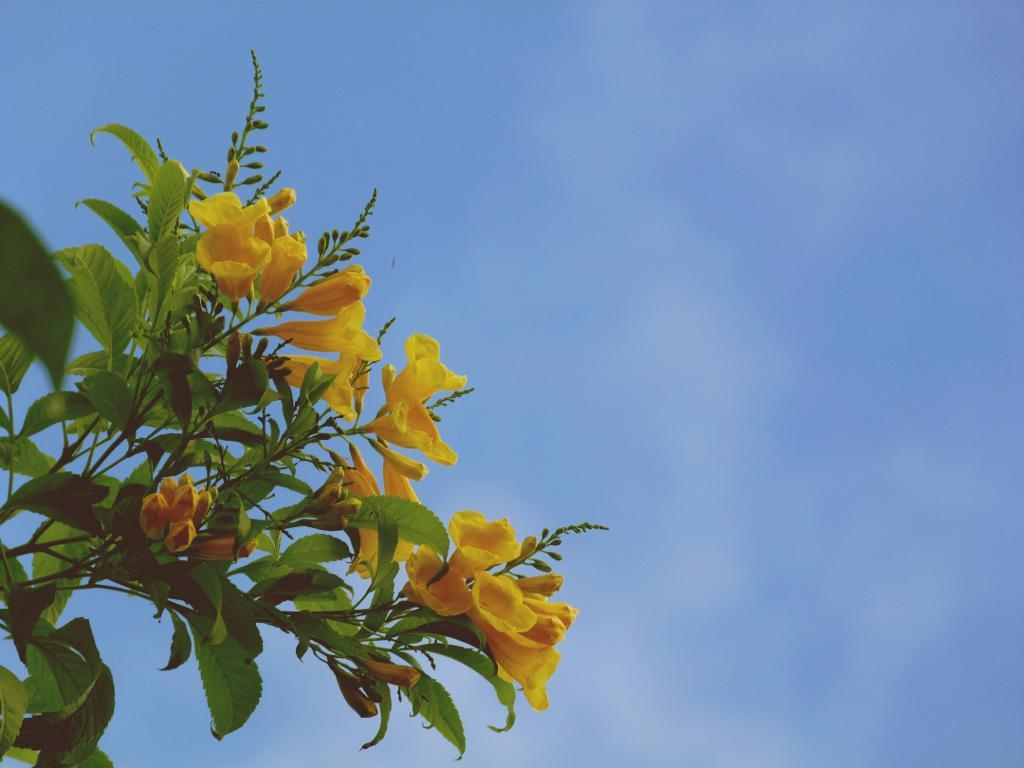What type of plants can be seen in the image? There are flower plants in the picture. What color are the flowers on the plants? The flowers are yellow in color. What can be seen in the background of the image? There is a sky visible in the background of the image. How many ducks are sitting on the tray in the image? There is no tray or ducks present in the image. 